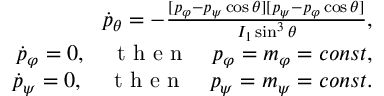<formula> <loc_0><loc_0><loc_500><loc_500>\begin{array} { r } { \dot { p } _ { \theta } = - \frac { [ p _ { \varphi } - p _ { \psi } \cos \theta ] [ p _ { \psi } - p _ { \varphi } \cos \theta ] } { I _ { 1 } \sin ^ { 3 } \theta } , } \\ { \dot { p } _ { \varphi } = 0 , \quad t h e n \quad p _ { \varphi } = m _ { \varphi } = c o n s t , } \\ { \dot { p } _ { \psi } = 0 , \quad t h e n \quad p _ { \psi } = m _ { \psi } = c o n s t . } \end{array}</formula> 